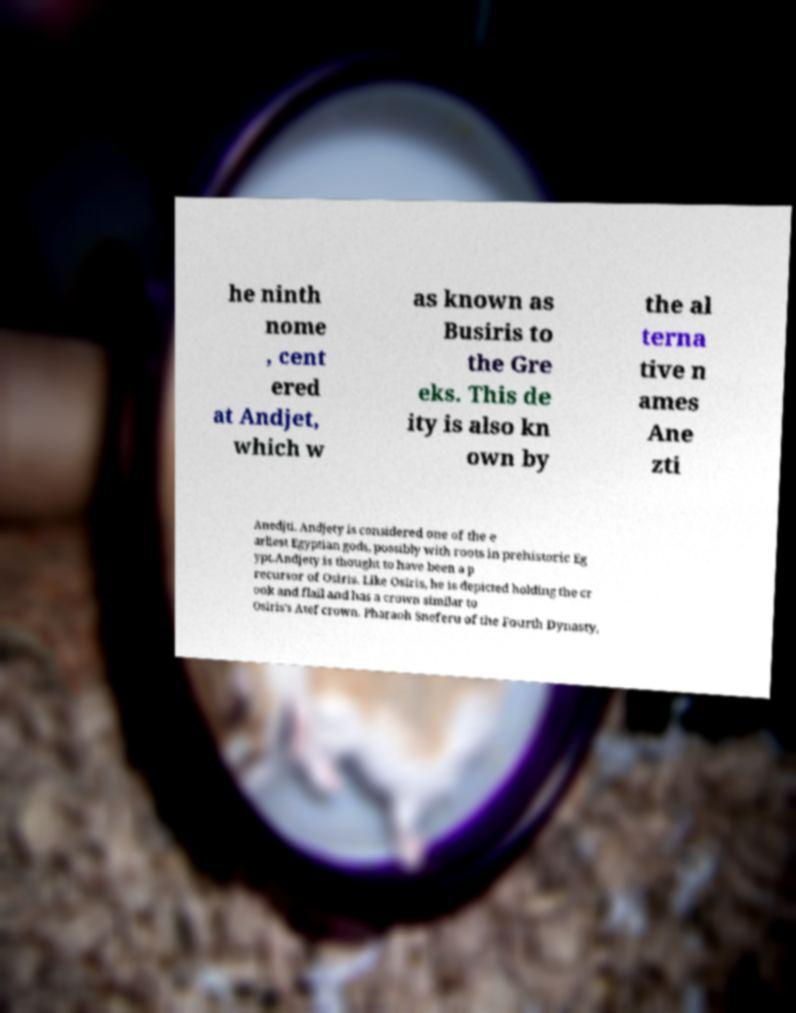I need the written content from this picture converted into text. Can you do that? he ninth nome , cent ered at Andjet, which w as known as Busiris to the Gre eks. This de ity is also kn own by the al terna tive n ames Ane zti Anedjti. Andjety is considered one of the e arliest Egyptian gods, possibly with roots in prehistoric Eg ypt.Andjety is thought to have been a p recursor of Osiris. Like Osiris, he is depicted holding the cr ook and flail and has a crown similar to Osiris's Atef crown. Pharaoh Sneferu of the Fourth Dynasty, 